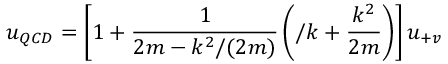Convert formula to latex. <formula><loc_0><loc_0><loc_500><loc_500>u _ { Q C D } = \left [ 1 + { \frac { 1 } { 2 m - k ^ { 2 } / ( 2 m ) } } \left ( \slash k + { \frac { k ^ { 2 } } { 2 m } } \right ) \right ] u _ { + v }</formula> 